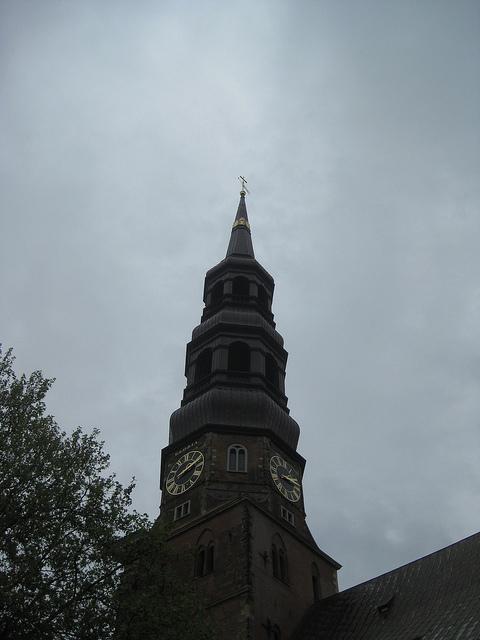Is there a way to tell time?
Answer briefly. Yes. What is at the top of the building?
Concise answer only. Cross. What is in the background of this photo?
Be succinct. Sky. Are there clouds?
Concise answer only. Yes. 